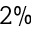Convert formula to latex. <formula><loc_0><loc_0><loc_500><loc_500>2 \%</formula> 